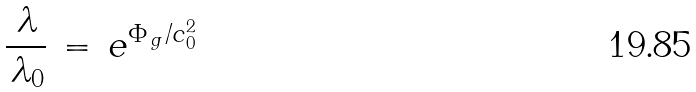Convert formula to latex. <formula><loc_0><loc_0><loc_500><loc_500>\frac { \, \lambda } { \, \lambda _ { 0 } } \, = \, e ^ { \Phi _ { \, g } / c _ { 0 } ^ { 2 } }</formula> 